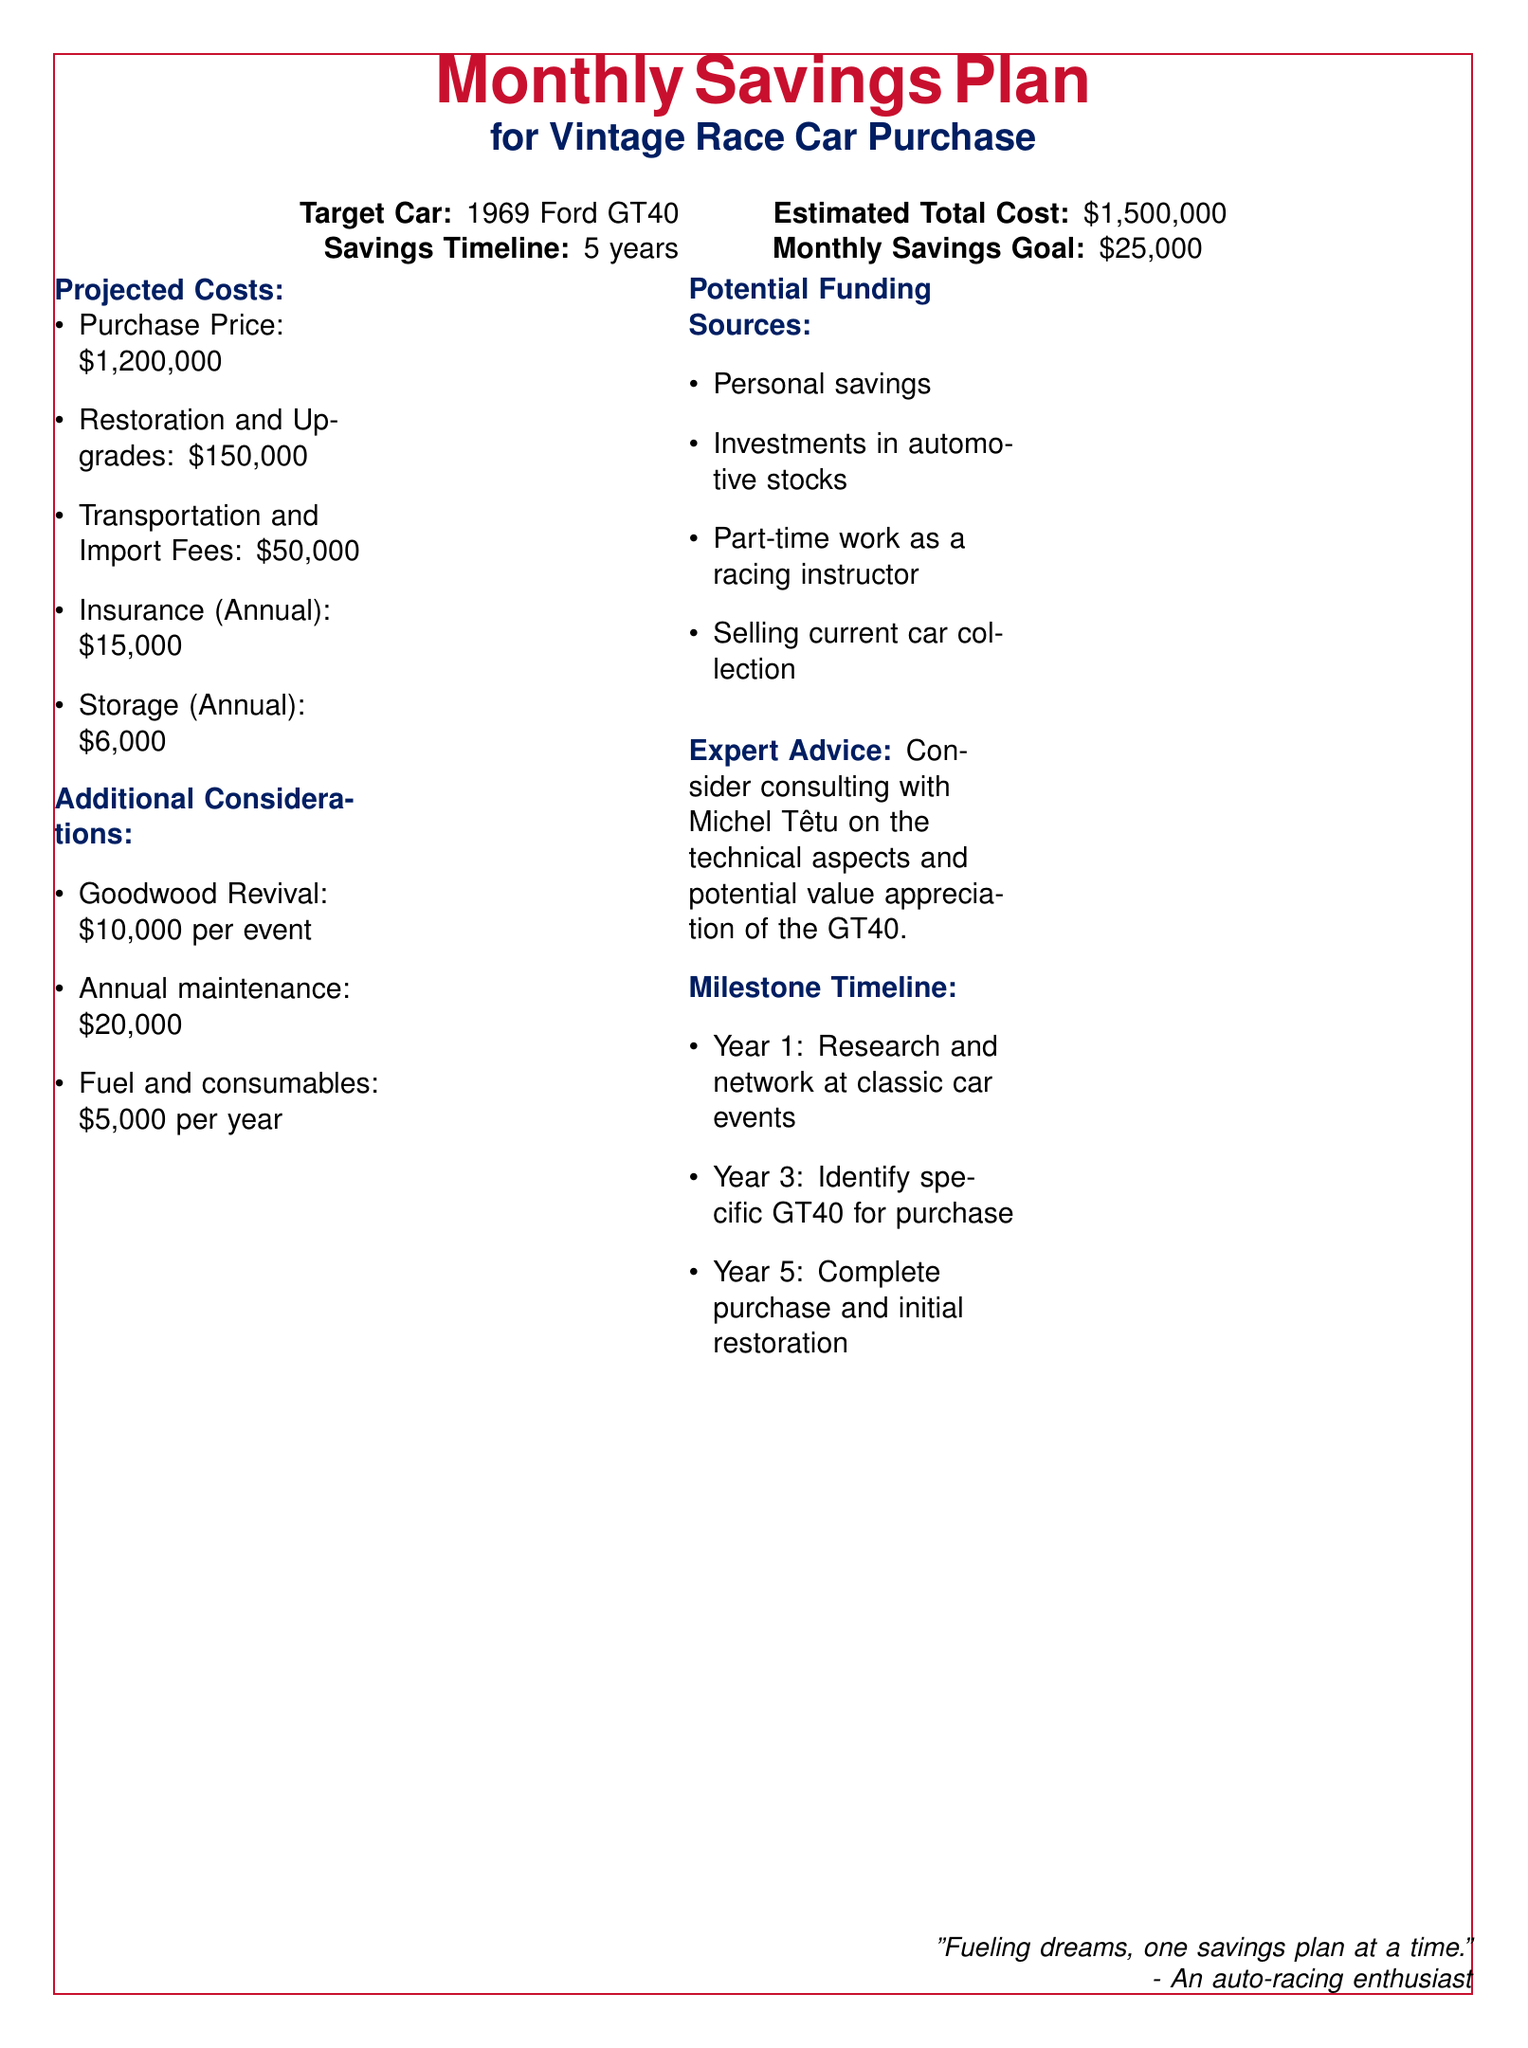What is the target car for the savings plan? The target car is specified in the document, which mentions a 1969 Ford GT40.
Answer: 1969 Ford GT40 What is the estimated total cost of the car? The estimated total cost of the car is explicitly stated in the document, listed as $1,500,000.
Answer: $1,500,000 How much should be saved monthly to achieve the goal? The document outlines the monthly savings goal, which is $25,000.
Answer: $25,000 What are the projected restoration and upgrade costs? The restoration and upgrade costs are separated in the projected costs section, which states $150,000.
Answer: $150,000 How many years is the savings timeline? The document specifies that the savings timeline is 5 years.
Answer: 5 years What is the annual insurance cost mentioned? The document indicates the annual insurance cost as $15,000.
Answer: $15,000 What is one potential funding source listed? The document includes several funding sources, one of which is personal savings.
Answer: Personal savings When is the completion of purchase and initial restoration planned? The milestone timeline in the document specifies Year 5 for the completion of purchase and initial restoration.
Answer: Year 5 What additional cost is associated with attending Goodwood Revival? The document mentions the cost for attending Goodwood Revival as $10,000 per event.
Answer: $10,000 per event 